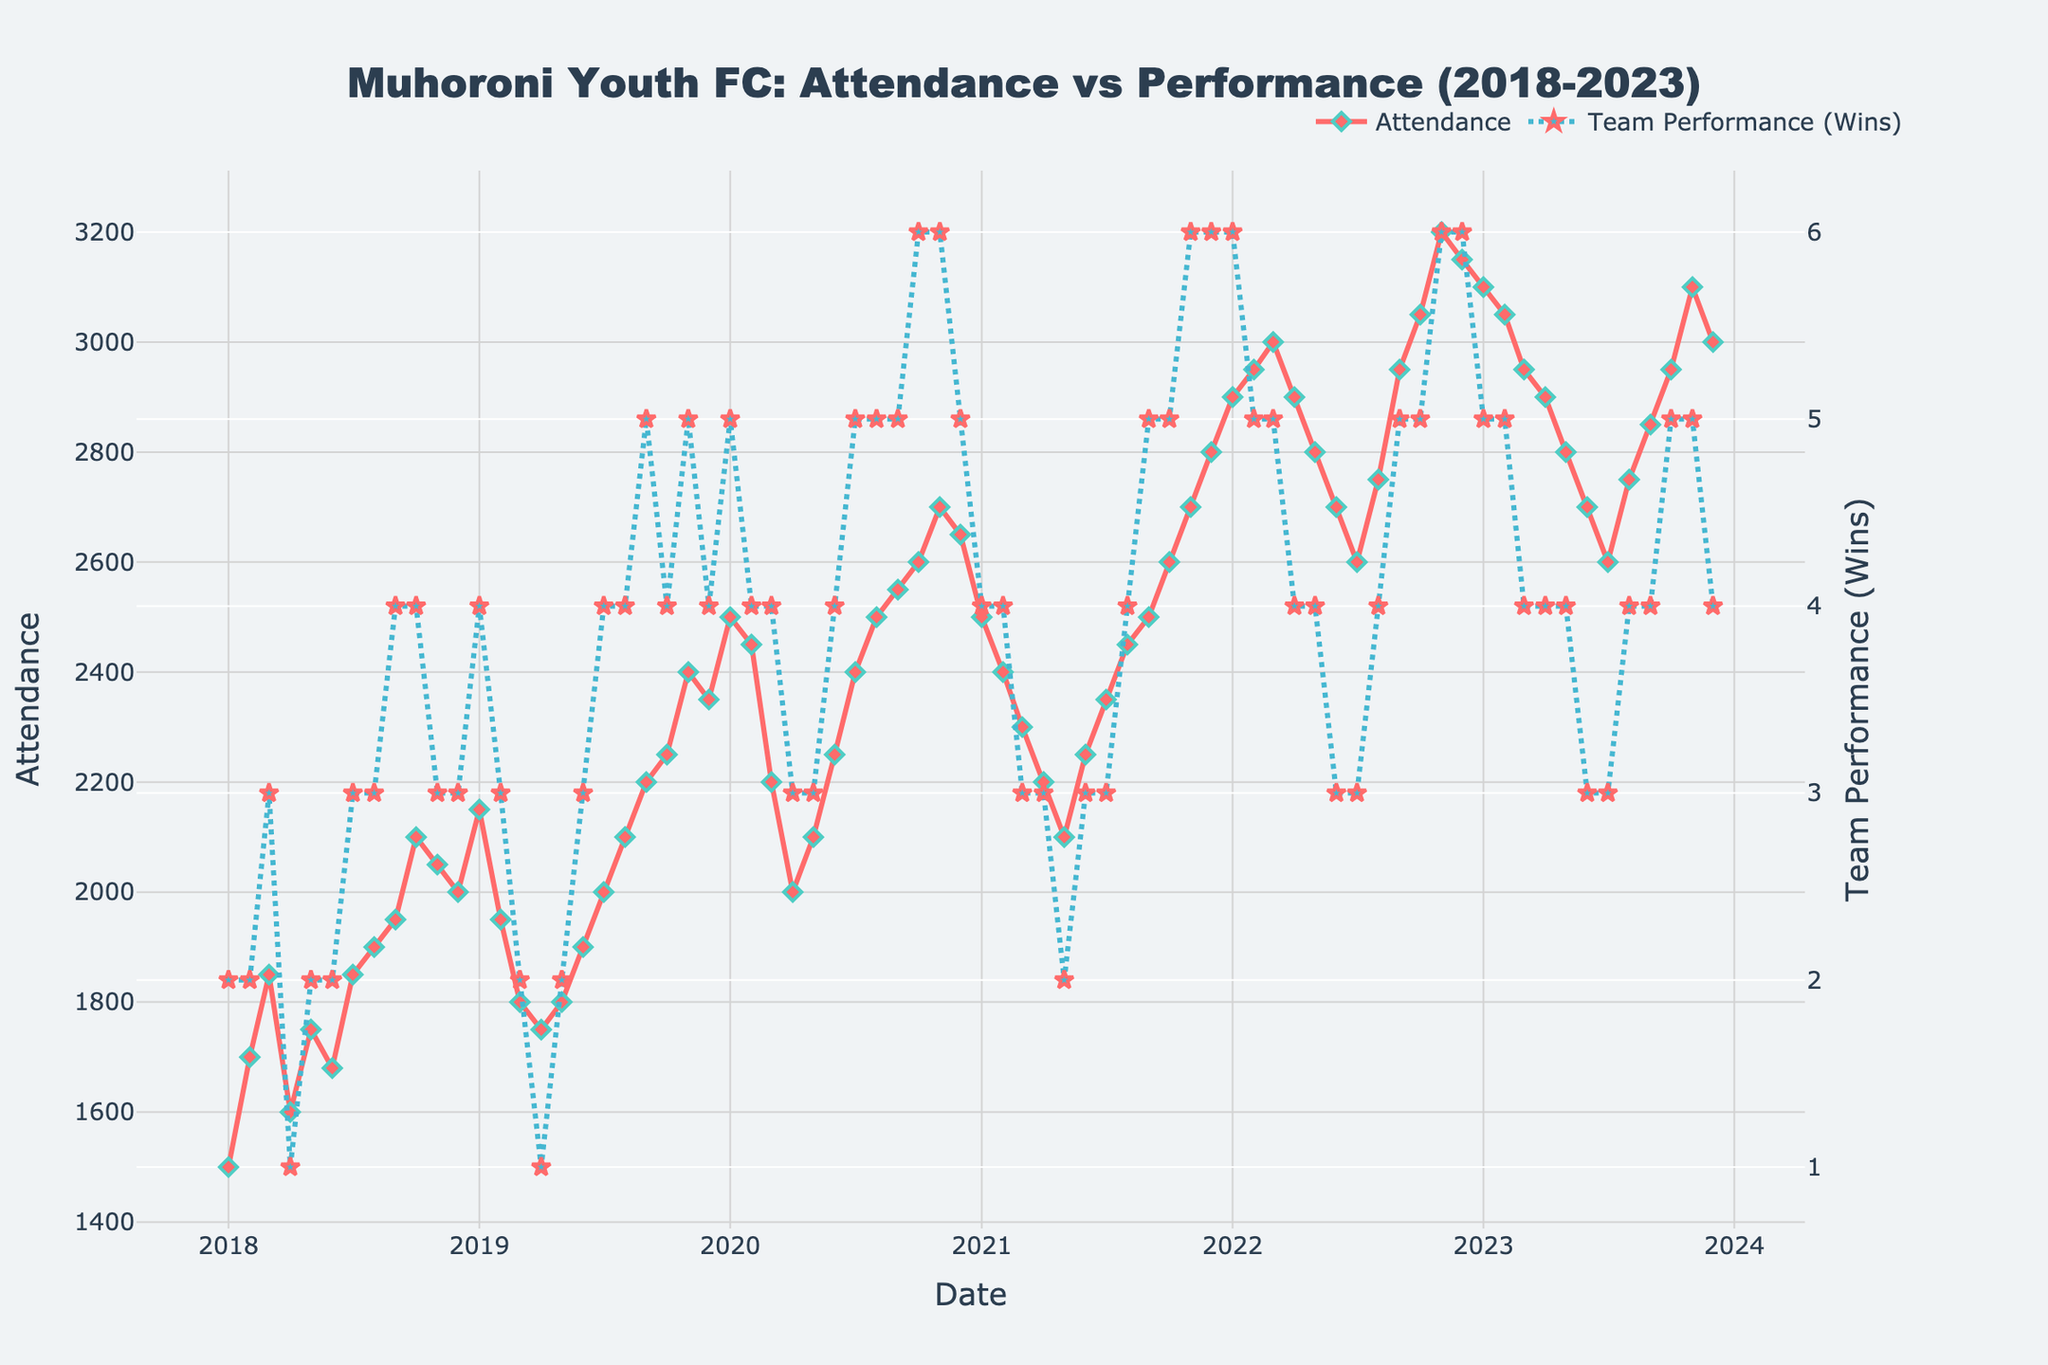What is the title of the plot? The title is located at the top of the plot and reads "Muhoroni Youth FC: Attendance vs Performance (2018-2023)."
Answer: Muhoroni Youth FC: Attendance vs Performance (2018-2023) What is the average attendance across all home games from 2018 to 2023? To find the average attendance, sum up all the attendance values and divide by the number of games. (Sum: 1,500+1,700+...+3,000 = 167,650; Number of games: 72; Average = 167,650 / 72 ≈ 2,328.)
Answer: Approximately 2,328 How did team performance in terms of wins change from January 2020 to January 2021? Look at the data points for January 2020 (5 wins) and January 2021 (4 wins) and compare the values.
Answer: Decreased by 1 win Did attendance and team performance follow a similar trend over the years? Visually compare the general direction of the two lines over time. Both attendance and team performance generally trend upward, with some fluctuations.
Answer: Yes, generally upward In which month and year did the attendance peak and what was the value? The peak attendance can be found where the 'Attendance' line reaches its highest point, which is in November 2022 with 3,200 attendees.
Answer: November 2022, 3,200 attendees What is the correlation between team performance and attendance? Visually inspect the plot to see how the trends in attendance and team performance are related—both tend to rise and fall together, suggesting a positive correlation.
Answer: Positive correlation Which year had the highest overall increase in attendance compared to the previous year? Calculate the yearly average attendance for each year and compare the increases. 2022 had the highest increase when comparing to previous year averages.
Answer: 2022 How does attendance in December 2023 compare to December 2018? Look at the attendance values for December 2018 (2,000) and December 2023 (3,000) and compare the values.
Answer: Increased by 1,000 attendees What is the lowest attendance recorded and in which month and year did it happen? Identify the lowest data point on the 'Attendance' line, which is in January 2018 with 1,500 attendees.
Answer: January 2018, 1,500 attendees What could be a possible reason for the sharp increase in attendance from January 2020? Observing the plot, note that team performance (wins) also increased around this time, likely contributing to higher attendance.
Answer: Increase in team performance (wins) 